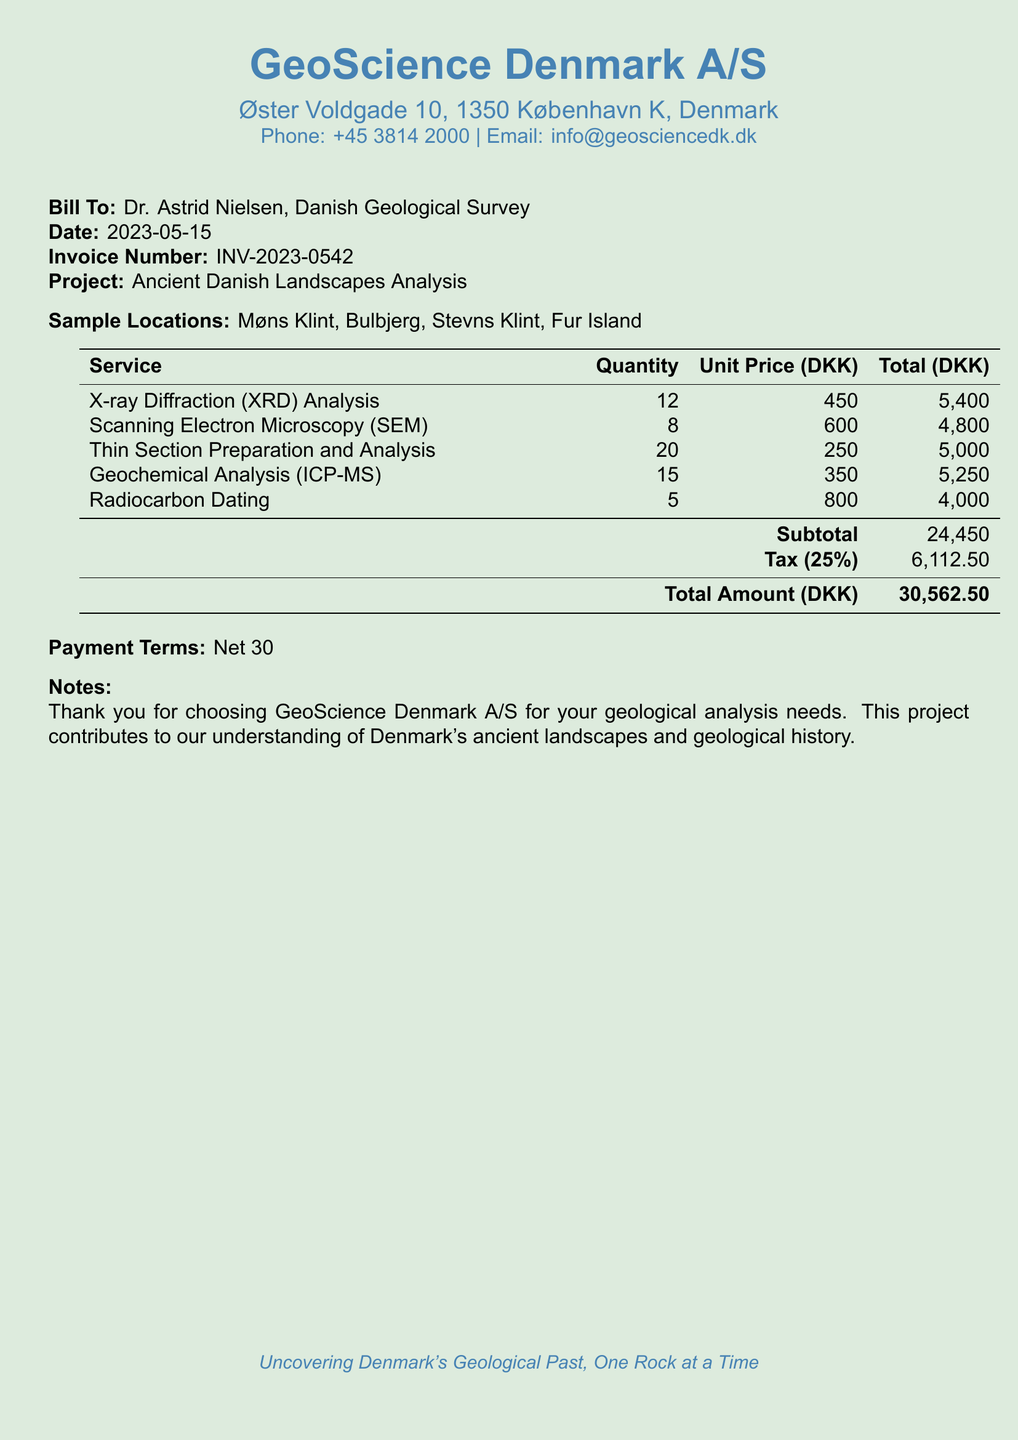what is the invoice number? The invoice number is specified in the document as a unique identifier for the billing, which is INV-2023-0542.
Answer: INV-2023-0542 who is the bill addressed to? The bill is addressed to a specific individual, which is mentioned at the beginning of the document, Dr. Astrid Nielsen.
Answer: Dr. Astrid Nielsen what is the total amount due? The total amount due is calculated after adding the subtotal and tax, which is presented as 30,562.50 DKK.
Answer: 30,562.50 DKK how many different types of analysis were conducted? The document lists the types of services provided, which total five different analyses conducted.
Answer: 5 what is the tax percentage applied? The tax percentage is noted in the document and is clearly stated as 25 percent applied to the subtotal.
Answer: 25% what is the subtotal before tax? The subtotal before tax is the total of all services rendered, which is indicated as 24,450 DKK.
Answer: 24,450 DKK what payment terms are specified? The payment terms are mentioned at the end of the document, indicating the net payment period expected from the client.
Answer: Net 30 which service has the highest unit price? The service with the highest unit price is identified in the document as Radiocarbon Dating at the price of 800 DKK per unit.
Answer: 800 DKK what is the quantity of Scanning Electron Microscopy tests performed? The quantity of Scanning Electron Microscopy tests is specified as part of the services provided in the document.
Answer: 8 